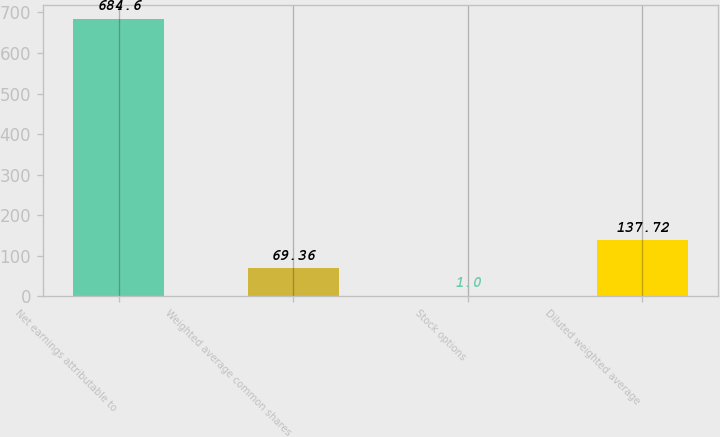Convert chart to OTSL. <chart><loc_0><loc_0><loc_500><loc_500><bar_chart><fcel>Net earnings attributable to<fcel>Weighted average common shares<fcel>Stock options<fcel>Diluted weighted average<nl><fcel>684.6<fcel>69.36<fcel>1<fcel>137.72<nl></chart> 